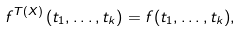<formula> <loc_0><loc_0><loc_500><loc_500>f ^ { T ( X ) } \left ( t _ { 1 } , \dots , t _ { k } \right ) = f ( t _ { 1 } , \dots , t _ { k } ) ,</formula> 